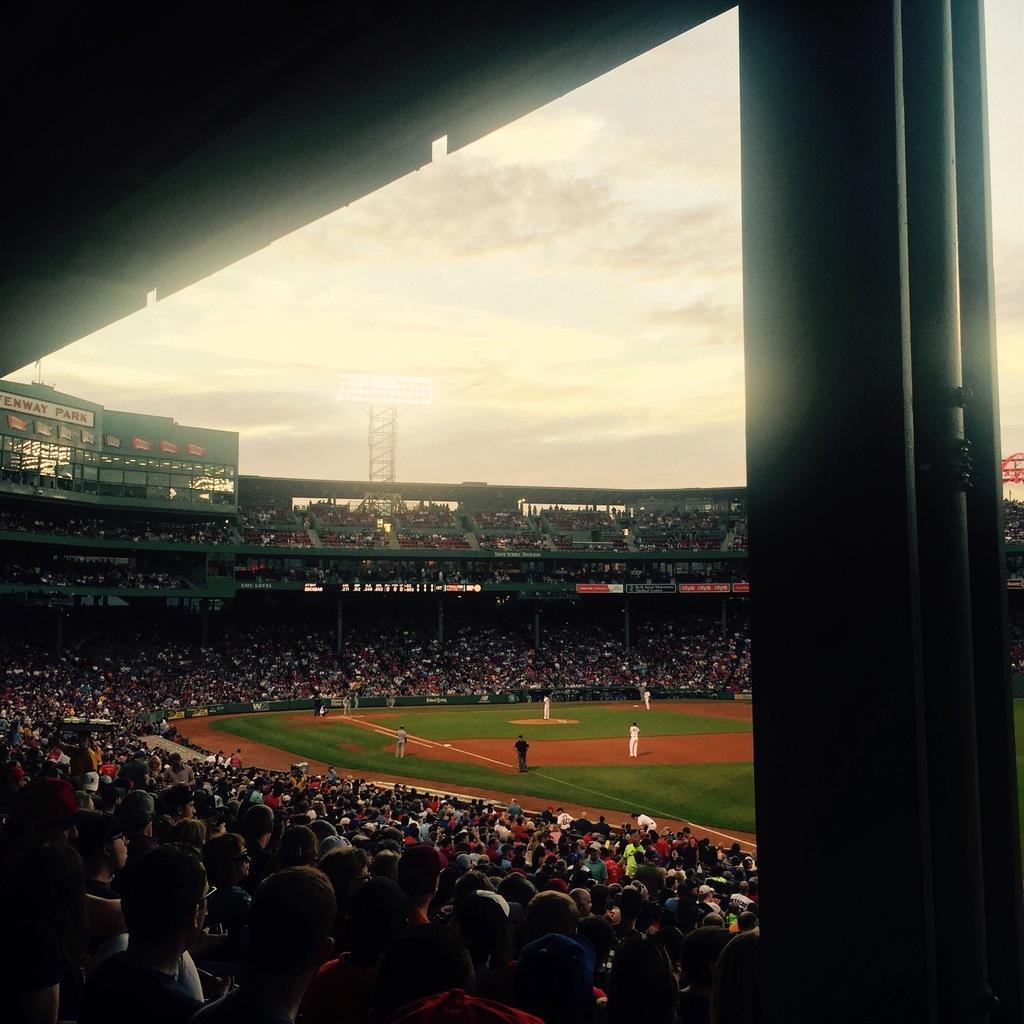Please provide a concise description of this image. In the image we can see there are many people wearing clothes and they are sitting. This is a stadium, ground, on the ground there are people playing, this is a pole, grass, lights and a cloudy sky. 